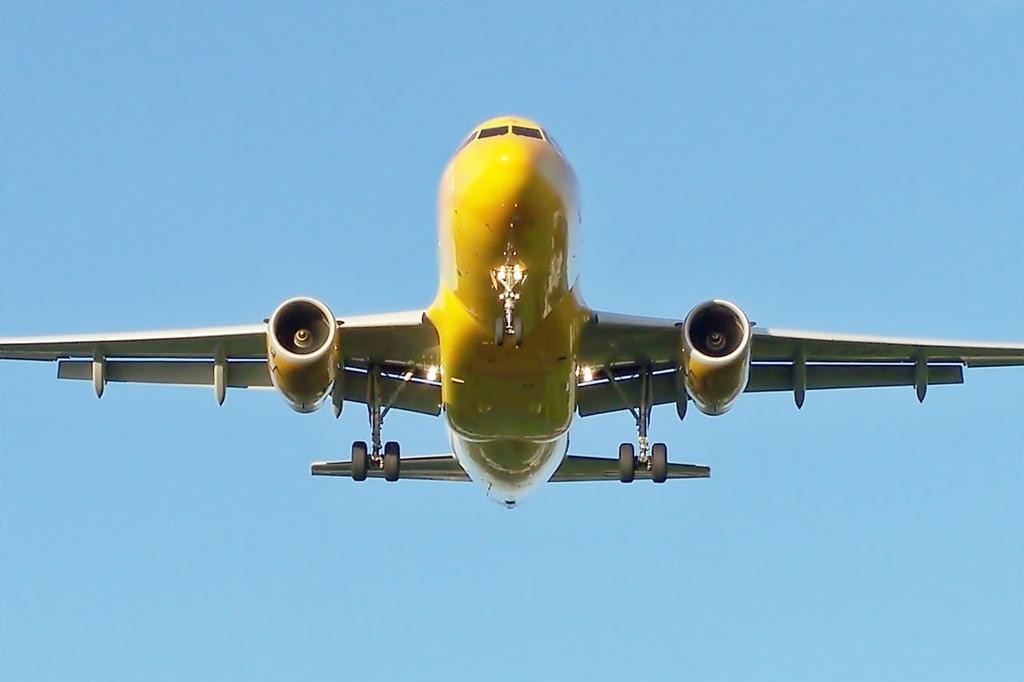What is the main subject of the image? The main subject of the image is an aircraft. Where is the aircraft located in the image? The aircraft is in the sky. What type of sink can be seen in the image? There is no sink present in the image; it features an aircraft in the sky. What type of school is depicted in the image? There is no school depicted in the image; it features an aircraft in the sky. 